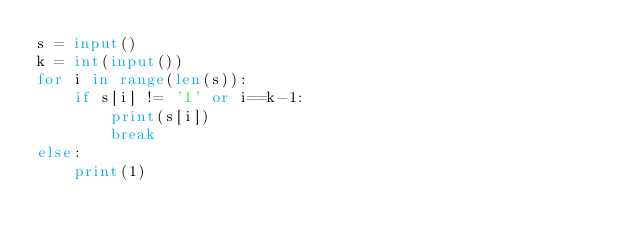Convert code to text. <code><loc_0><loc_0><loc_500><loc_500><_Python_>s = input()
k = int(input())
for i in range(len(s)):
    if s[i] != '1' or i==k-1:
        print(s[i])
        break
else:
    print(1)</code> 